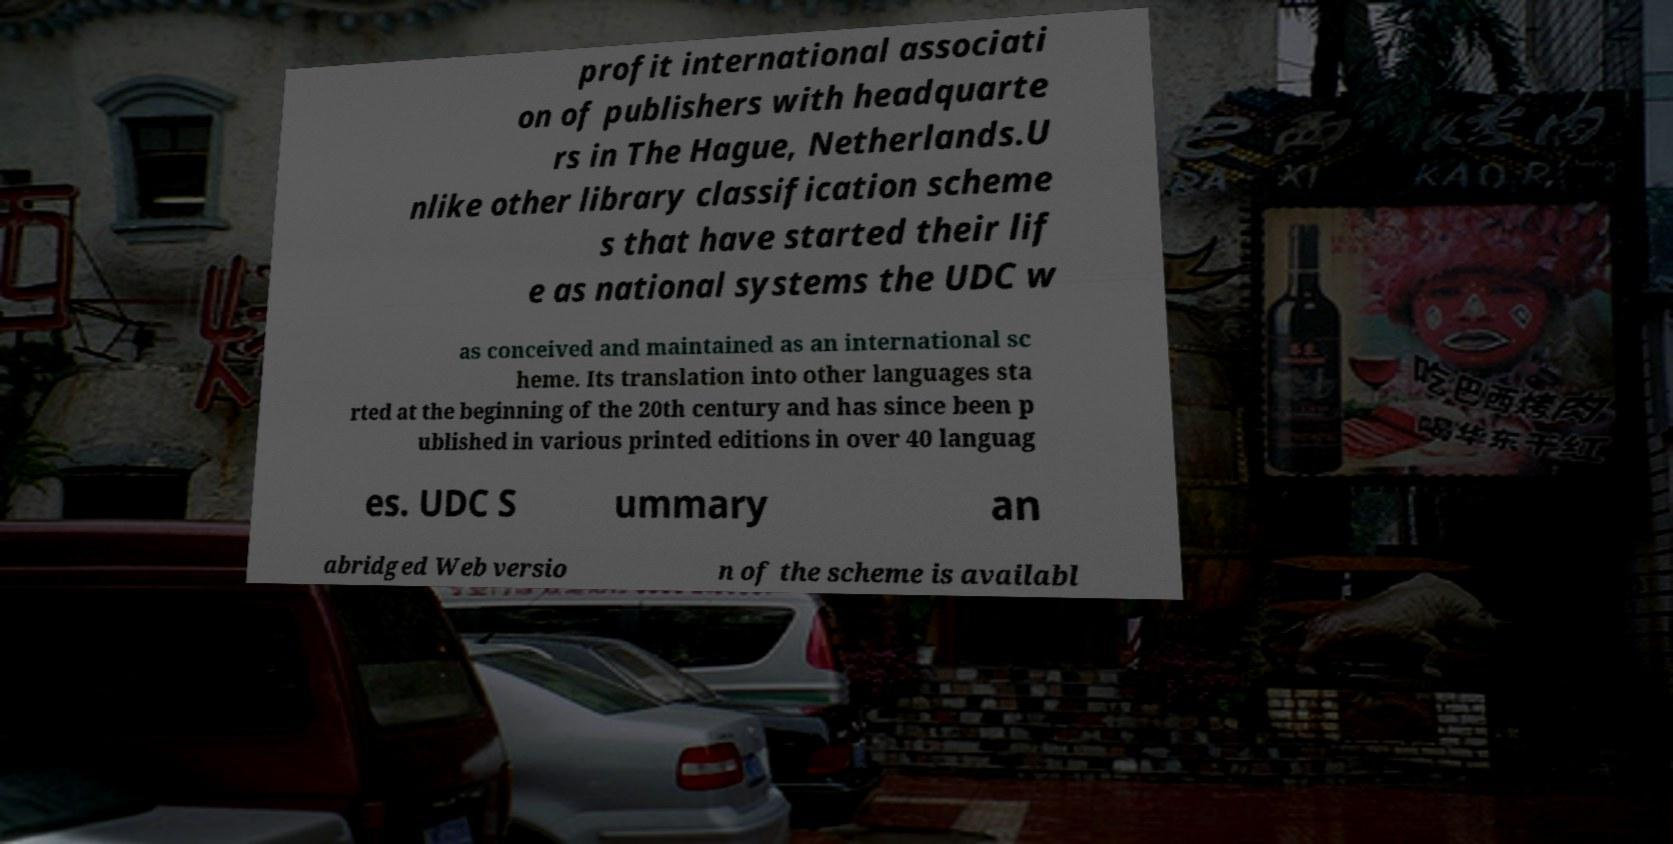For documentation purposes, I need the text within this image transcribed. Could you provide that? profit international associati on of publishers with headquarte rs in The Hague, Netherlands.U nlike other library classification scheme s that have started their lif e as national systems the UDC w as conceived and maintained as an international sc heme. Its translation into other languages sta rted at the beginning of the 20th century and has since been p ublished in various printed editions in over 40 languag es. UDC S ummary an abridged Web versio n of the scheme is availabl 